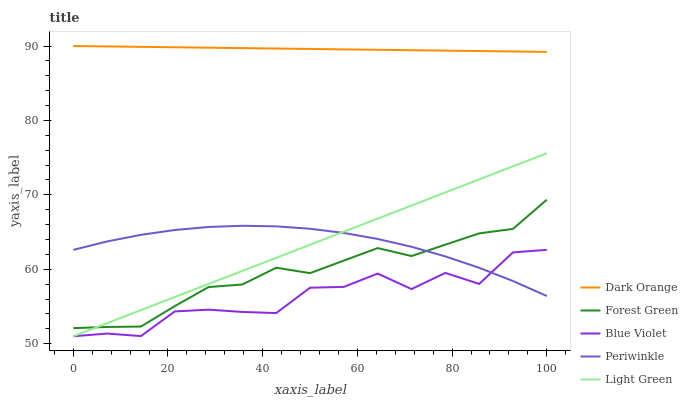Does Blue Violet have the minimum area under the curve?
Answer yes or no. Yes. Does Dark Orange have the maximum area under the curve?
Answer yes or no. Yes. Does Forest Green have the minimum area under the curve?
Answer yes or no. No. Does Forest Green have the maximum area under the curve?
Answer yes or no. No. Is Light Green the smoothest?
Answer yes or no. Yes. Is Blue Violet the roughest?
Answer yes or no. Yes. Is Forest Green the smoothest?
Answer yes or no. No. Is Forest Green the roughest?
Answer yes or no. No. Does Light Green have the lowest value?
Answer yes or no. Yes. Does Forest Green have the lowest value?
Answer yes or no. No. Does Dark Orange have the highest value?
Answer yes or no. Yes. Does Forest Green have the highest value?
Answer yes or no. No. Is Forest Green less than Dark Orange?
Answer yes or no. Yes. Is Dark Orange greater than Blue Violet?
Answer yes or no. Yes. Does Blue Violet intersect Periwinkle?
Answer yes or no. Yes. Is Blue Violet less than Periwinkle?
Answer yes or no. No. Is Blue Violet greater than Periwinkle?
Answer yes or no. No. Does Forest Green intersect Dark Orange?
Answer yes or no. No. 